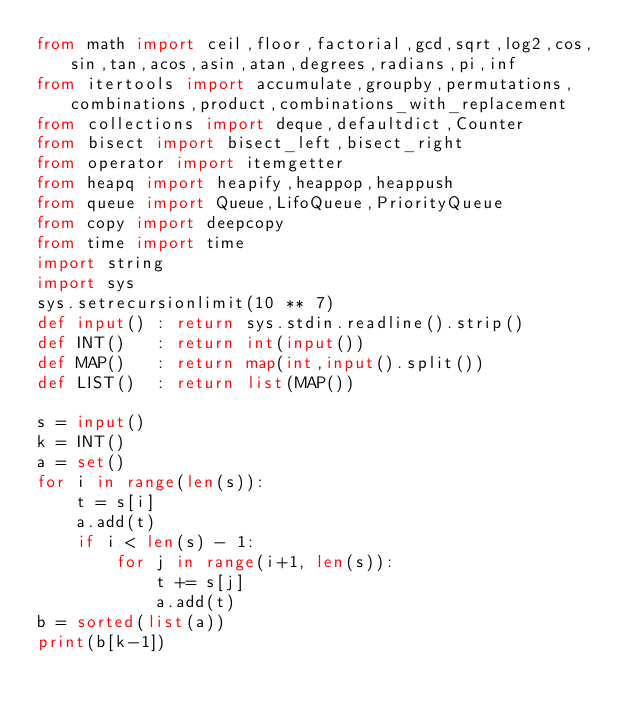Convert code to text. <code><loc_0><loc_0><loc_500><loc_500><_Python_>from math import ceil,floor,factorial,gcd,sqrt,log2,cos,sin,tan,acos,asin,atan,degrees,radians,pi,inf
from itertools import accumulate,groupby,permutations,combinations,product,combinations_with_replacement
from collections import deque,defaultdict,Counter
from bisect import bisect_left,bisect_right
from operator import itemgetter
from heapq import heapify,heappop,heappush
from queue import Queue,LifoQueue,PriorityQueue
from copy import deepcopy
from time import time
import string
import sys
sys.setrecursionlimit(10 ** 7)
def input() : return sys.stdin.readline().strip()
def INT()   : return int(input())
def MAP()   : return map(int,input().split())
def LIST()  : return list(MAP())

s = input()
k = INT()
a = set()
for i in range(len(s)):
    t = s[i]
    a.add(t)
    if i < len(s) - 1:
        for j in range(i+1, len(s)):
            t += s[j]
            a.add(t)
b = sorted(list(a))
print(b[k-1])</code> 